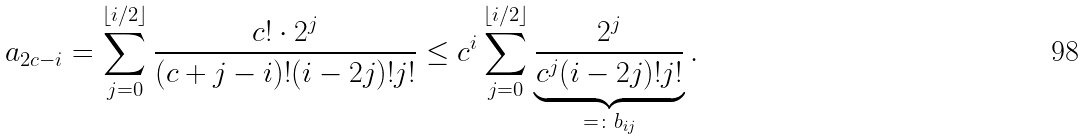Convert formula to latex. <formula><loc_0><loc_0><loc_500><loc_500>a _ { 2 c - i } = \sum _ { j = 0 } ^ { \lfloor i / 2 \rfloor } \frac { c ! \cdot 2 ^ { j } } { ( c + j - i ) ! ( i - 2 j ) ! j ! } \leq c ^ { i } \sum _ { j = 0 } ^ { \lfloor i / 2 \rfloor } \underbrace { \frac { 2 ^ { j } } { c ^ { j } ( i - 2 j ) ! j ! } } _ { = \colon b _ { i j } } .</formula> 